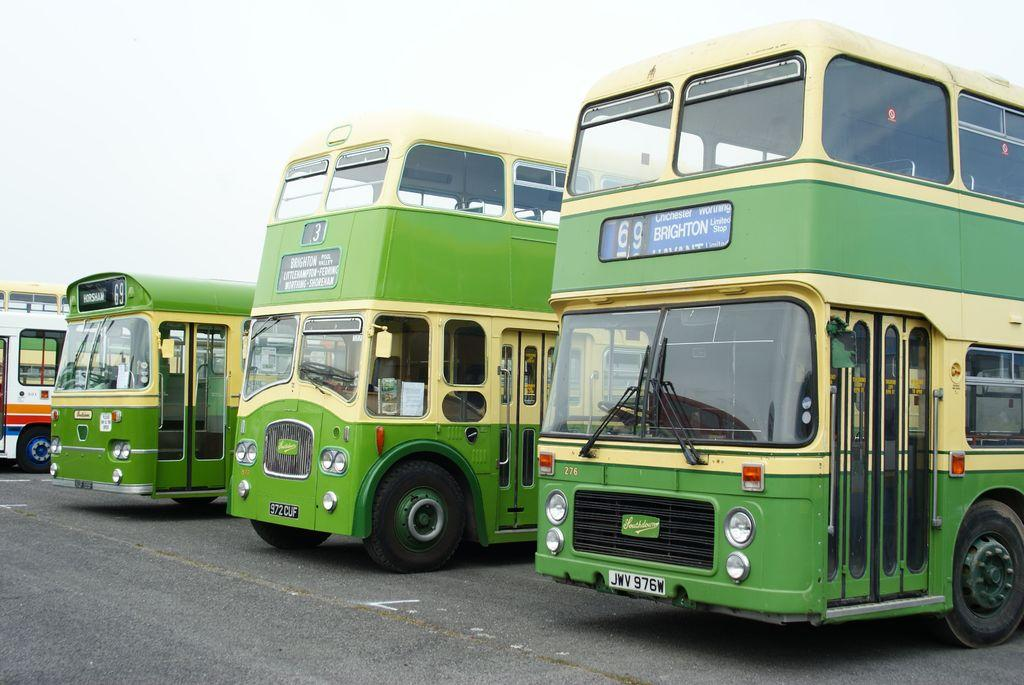<image>
Summarize the visual content of the image. The bus on the right with license plate number JWV 976W. 